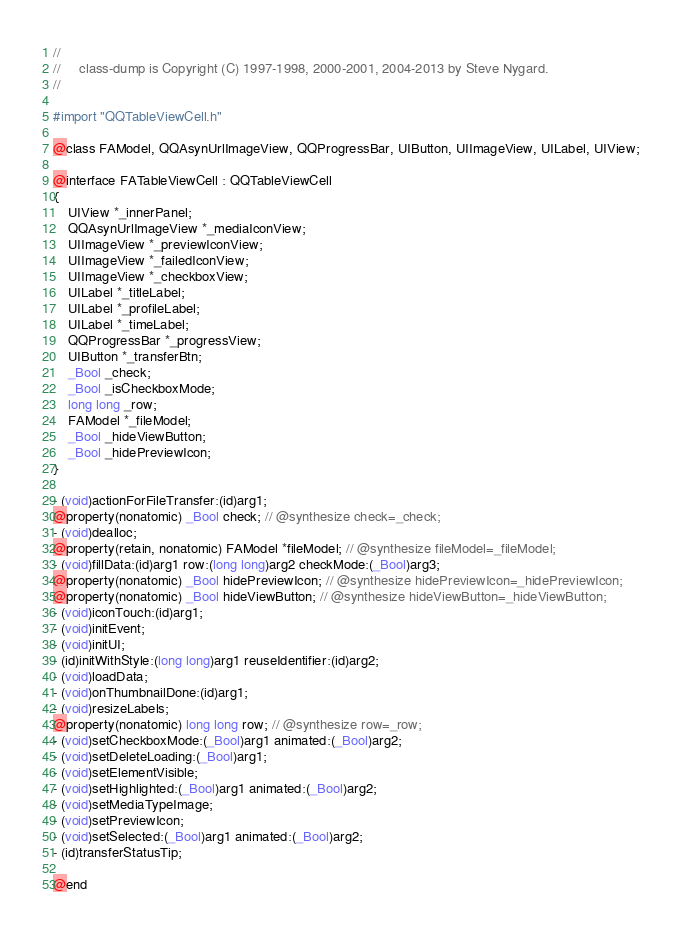Convert code to text. <code><loc_0><loc_0><loc_500><loc_500><_C_>//
//     class-dump is Copyright (C) 1997-1998, 2000-2001, 2004-2013 by Steve Nygard.
//

#import "QQTableViewCell.h"

@class FAModel, QQAsynUrlImageView, QQProgressBar, UIButton, UIImageView, UILabel, UIView;

@interface FATableViewCell : QQTableViewCell
{
    UIView *_innerPanel;
    QQAsynUrlImageView *_mediaIconView;
    UIImageView *_previewIconView;
    UIImageView *_failedIconView;
    UIImageView *_checkboxView;
    UILabel *_titleLabel;
    UILabel *_profileLabel;
    UILabel *_timeLabel;
    QQProgressBar *_progressView;
    UIButton *_transferBtn;
    _Bool _check;
    _Bool _isCheckboxMode;
    long long _row;
    FAModel *_fileModel;
    _Bool _hideViewButton;
    _Bool _hidePreviewIcon;
}

- (void)actionForFileTransfer:(id)arg1;
@property(nonatomic) _Bool check; // @synthesize check=_check;
- (void)dealloc;
@property(retain, nonatomic) FAModel *fileModel; // @synthesize fileModel=_fileModel;
- (void)fillData:(id)arg1 row:(long long)arg2 checkMode:(_Bool)arg3;
@property(nonatomic) _Bool hidePreviewIcon; // @synthesize hidePreviewIcon=_hidePreviewIcon;
@property(nonatomic) _Bool hideViewButton; // @synthesize hideViewButton=_hideViewButton;
- (void)iconTouch:(id)arg1;
- (void)initEvent;
- (void)initUI;
- (id)initWithStyle:(long long)arg1 reuseIdentifier:(id)arg2;
- (void)loadData;
- (void)onThumbnailDone:(id)arg1;
- (void)resizeLabels;
@property(nonatomic) long long row; // @synthesize row=_row;
- (void)setCheckboxMode:(_Bool)arg1 animated:(_Bool)arg2;
- (void)setDeleteLoading:(_Bool)arg1;
- (void)setElementVisible;
- (void)setHighlighted:(_Bool)arg1 animated:(_Bool)arg2;
- (void)setMediaTypeImage;
- (void)setPreviewIcon;
- (void)setSelected:(_Bool)arg1 animated:(_Bool)arg2;
- (id)transferStatusTip;

@end

</code> 